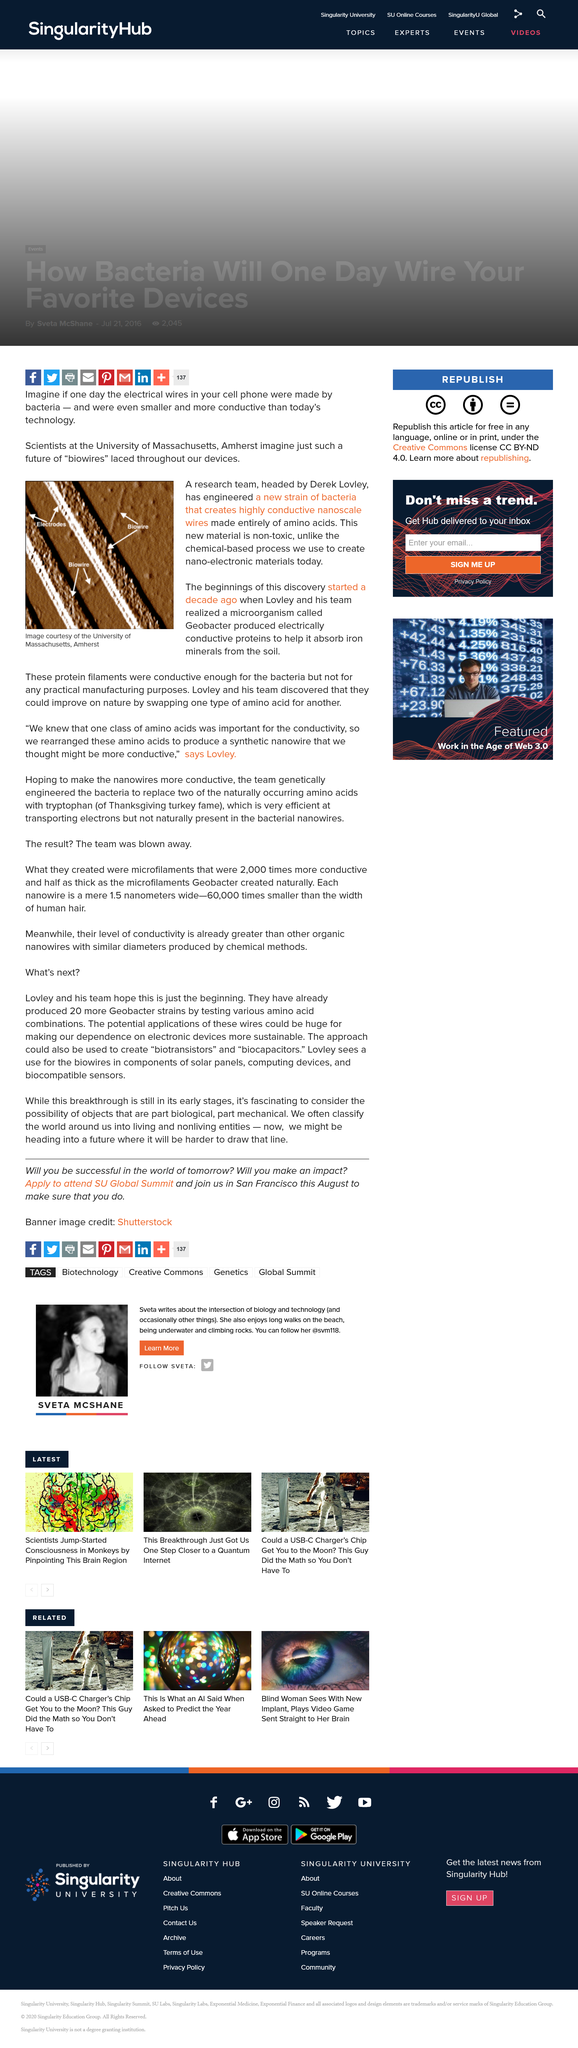Draw attention to some important aspects in this diagram. Geobacter is a microorganism that produces electrically conductive proteins to help it absorb iron minerals from the soil. This microorganism is known for its ability to conduct electricity and play a crucial role in the cycling of iron in the environment. A team based at the University of Massachusetts discovered something. The scientist who heads the team is named Derek. 